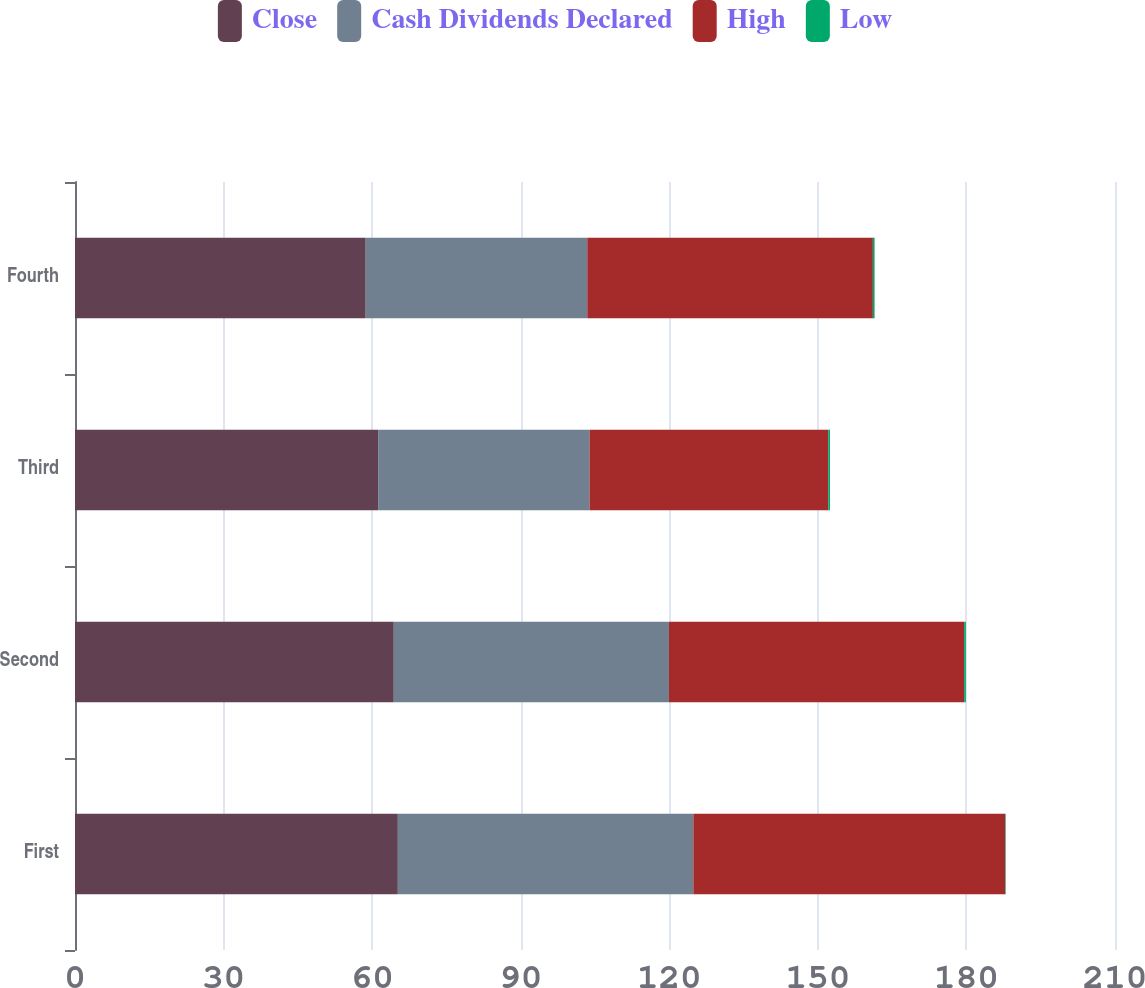Convert chart to OTSL. <chart><loc_0><loc_0><loc_500><loc_500><stacked_bar_chart><ecel><fcel>First<fcel>Second<fcel>Third<fcel>Fourth<nl><fcel>Close<fcel>65.19<fcel>64.37<fcel>61.21<fcel>58.7<nl><fcel>Cash Dividends Declared<fcel>59.67<fcel>55.56<fcel>42.7<fcel>44.74<nl><fcel>High<fcel>62.99<fcel>59.61<fcel>48.19<fcel>57.67<nl><fcel>Low<fcel>0.1<fcel>0.35<fcel>0.35<fcel>0.35<nl></chart> 